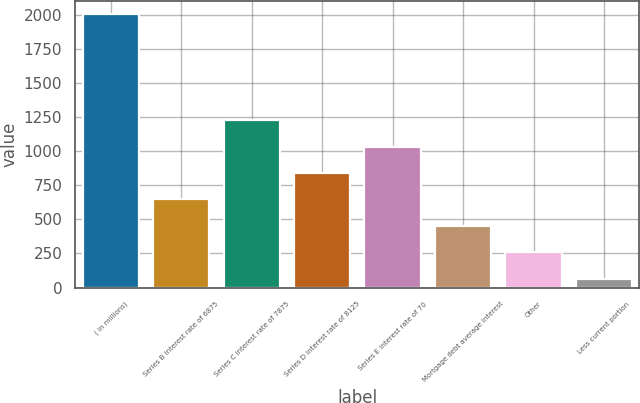Convert chart. <chart><loc_0><loc_0><loc_500><loc_500><bar_chart><fcel>( in millions)<fcel>Series B interest rate of 6875<fcel>Series C interest rate of 7875<fcel>Series D interest rate of 8125<fcel>Series E interest rate of 70<fcel>Mortgage debt average interest<fcel>Other<fcel>Less current portion<nl><fcel>2003<fcel>645.7<fcel>1227.4<fcel>839.6<fcel>1033.5<fcel>451.8<fcel>257.9<fcel>64<nl></chart> 